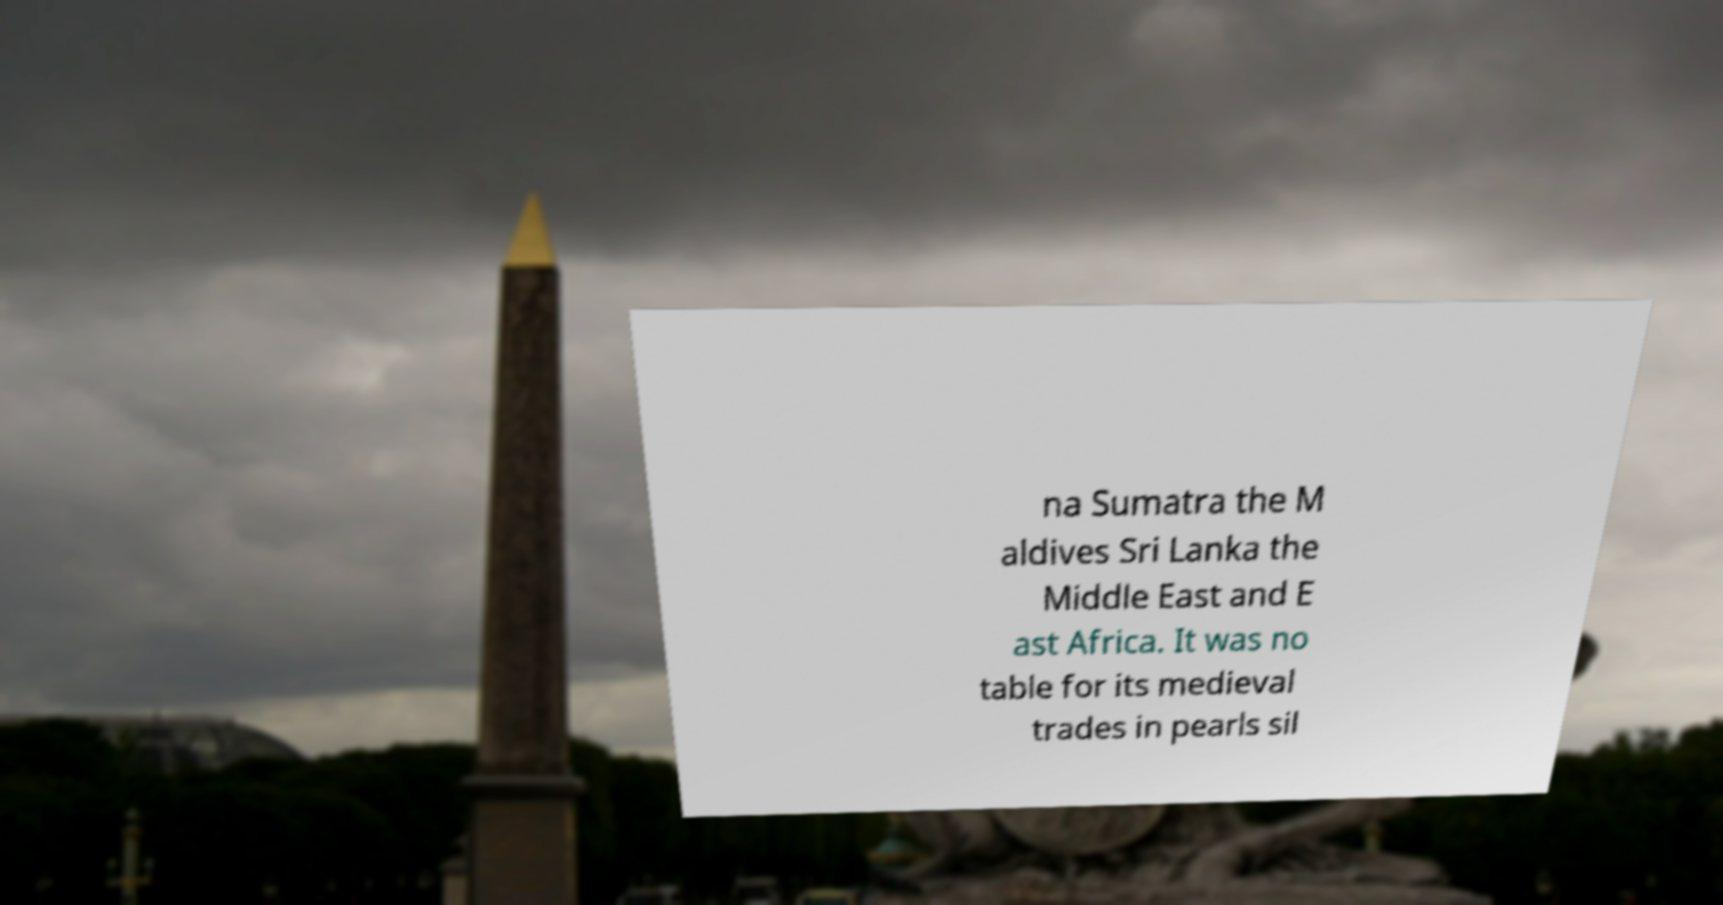Please identify and transcribe the text found in this image. na Sumatra the M aldives Sri Lanka the Middle East and E ast Africa. It was no table for its medieval trades in pearls sil 